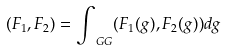<formula> <loc_0><loc_0><loc_500><loc_500>( F _ { 1 } , F _ { 2 } ) = \int _ { \ G G } ( F _ { 1 } ( g ) , F _ { 2 } ( g ) ) d g</formula> 